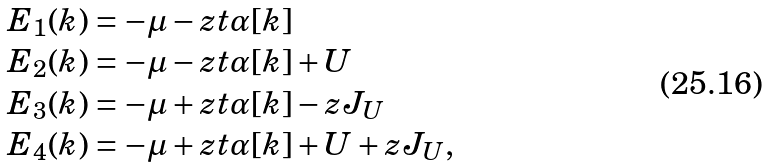<formula> <loc_0><loc_0><loc_500><loc_500>\begin{array} { l } E _ { 1 } ( { k } ) = - \mu - z t \alpha [ { k } ] \\ E _ { 2 } ( { k } ) = - \mu - z t \alpha [ { k } ] + U \\ E _ { 3 } ( { k } ) = - \mu + z t \alpha [ { k } ] - z J _ { U } \\ E _ { 4 } ( { k } ) = - \mu + z t \alpha [ { k } ] + U + z J _ { U } , \end{array}</formula> 